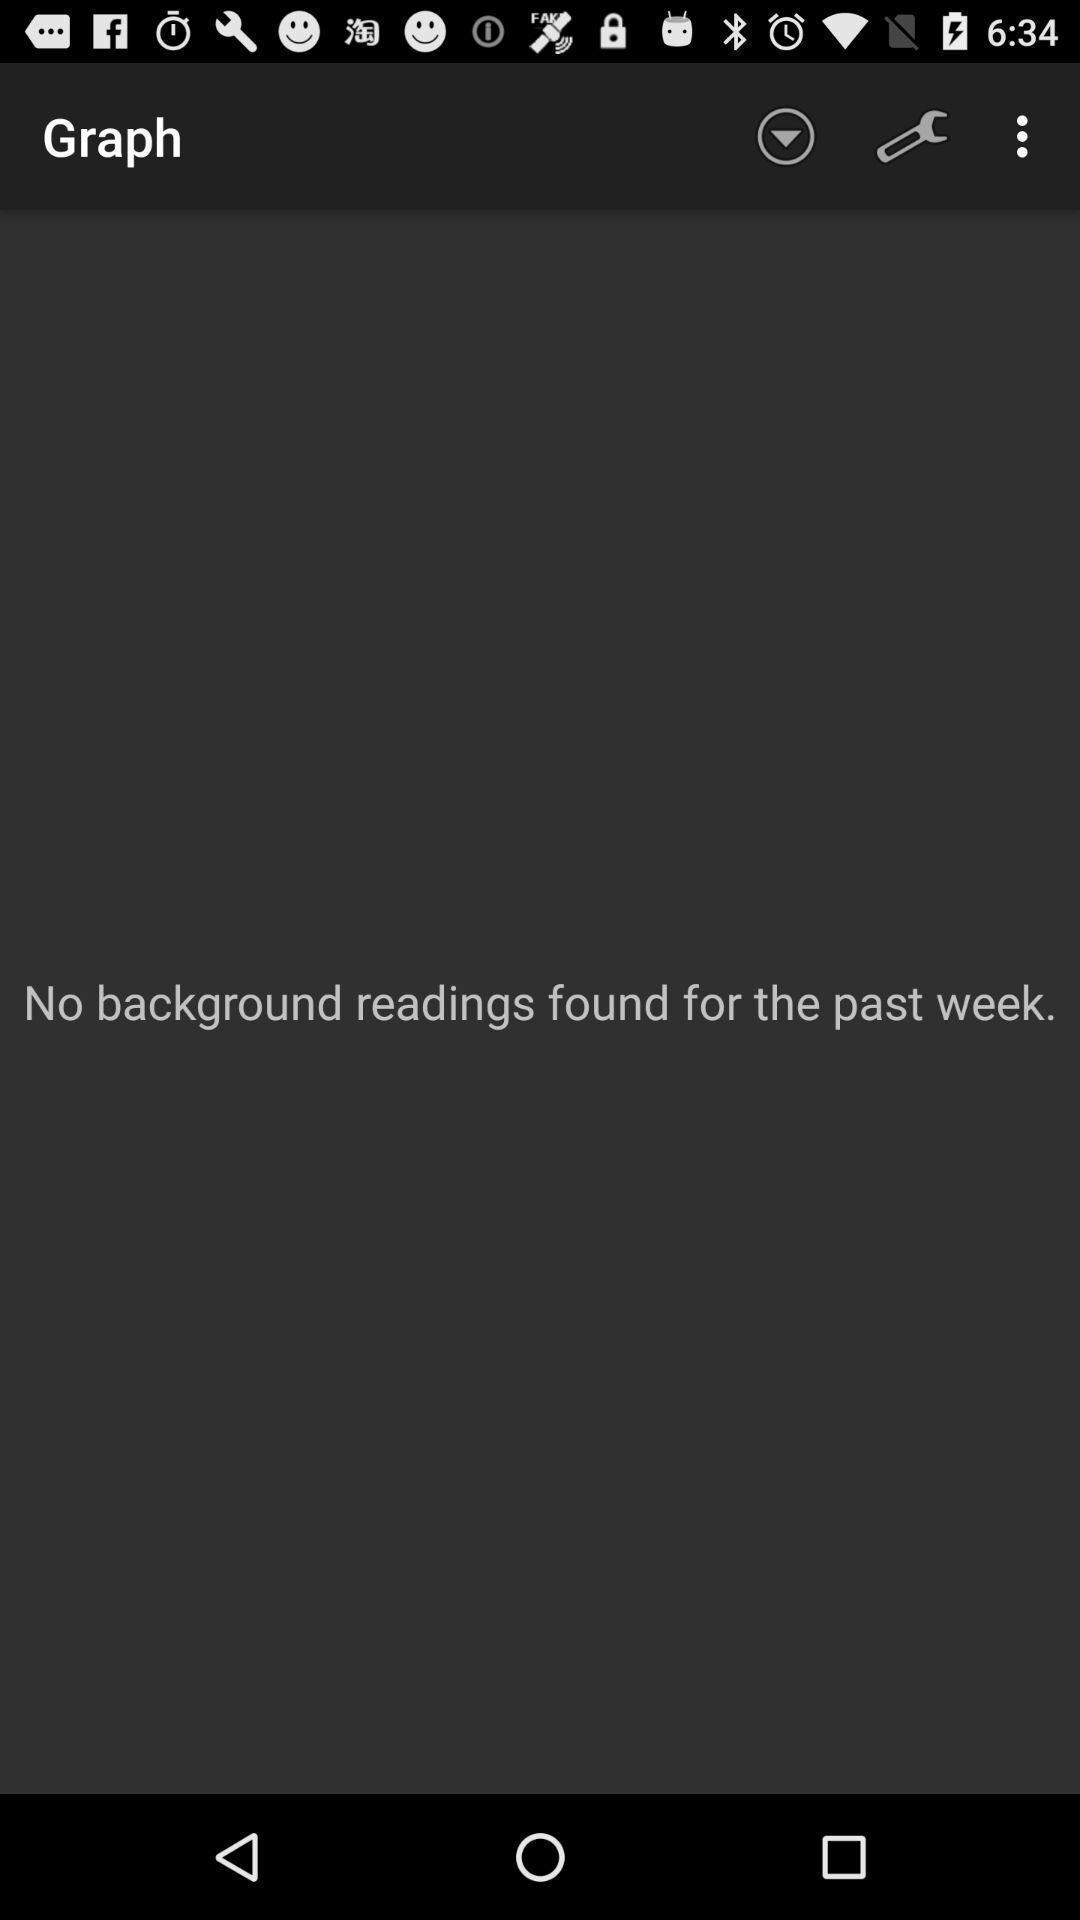Give me a narrative description of this picture. Page showing interface for a meteorology related app. 